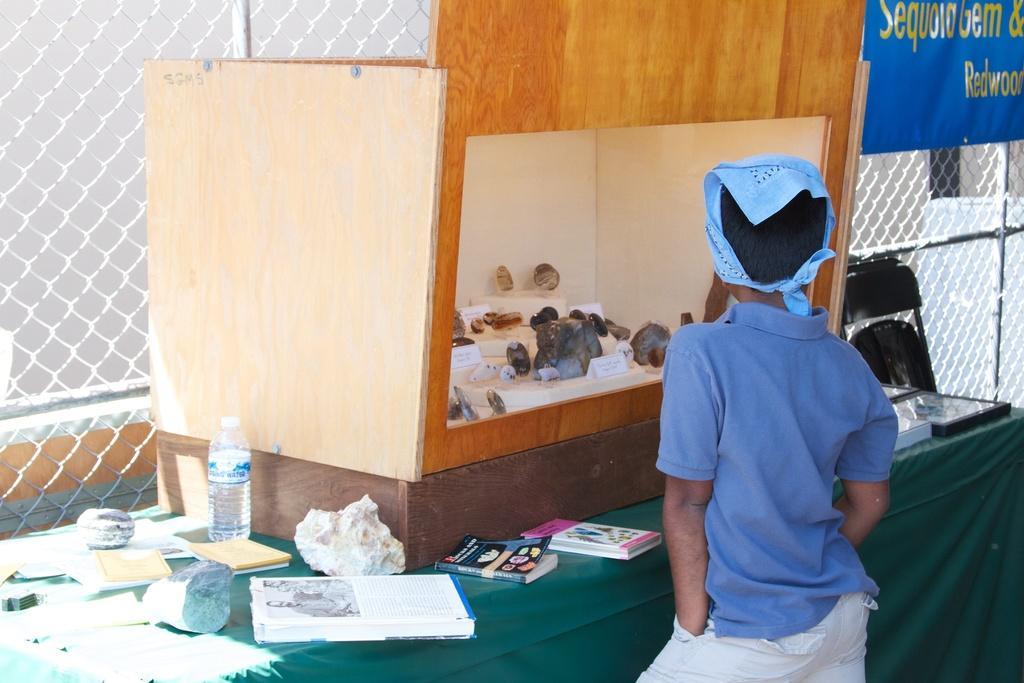Can you describe this image briefly? In this image we can see a boy standing at the table. On the table we can see water bottle, books, chair. In the background we can see grill and wall. 